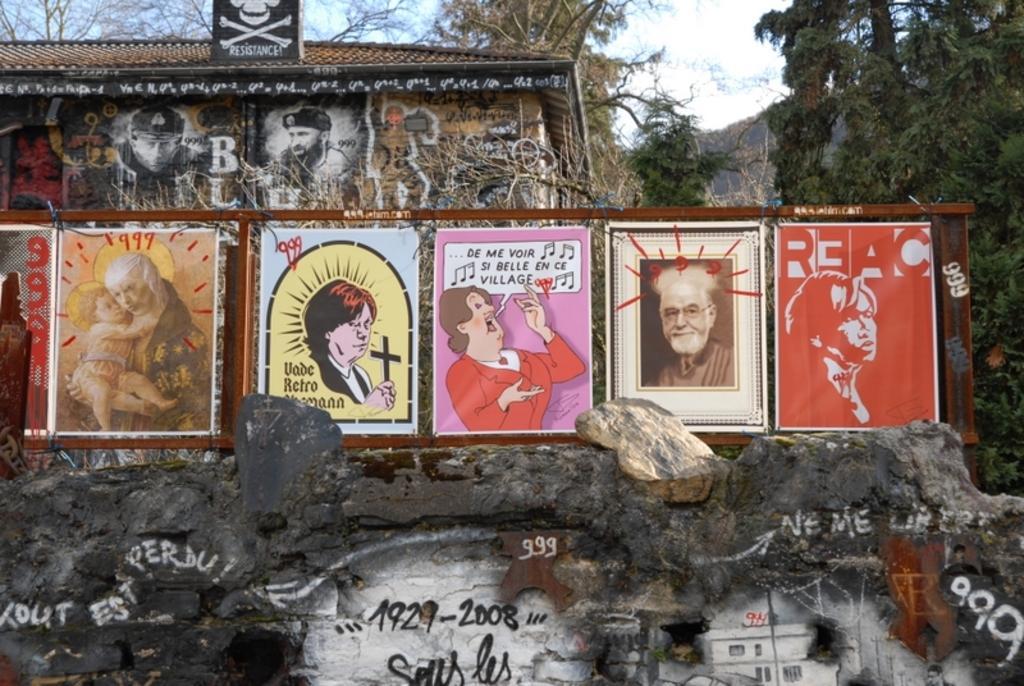Could you give a brief overview of what you see in this image? In this image we can see boards. At the bottom there is a wall and we can see graffiti on the wall. In the background there is a shed and we can see trees. At the top there is sky. 